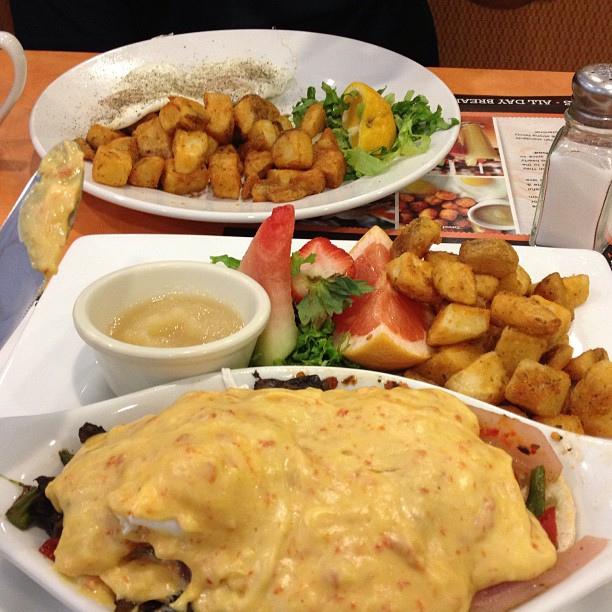Is there fruit on the plate?
Short answer required. Yes. What is in the shaker?
Give a very brief answer. Salt. What was in the bowl?
Short answer required. Potatoes. What meal is this?
Answer briefly. Dinner. 